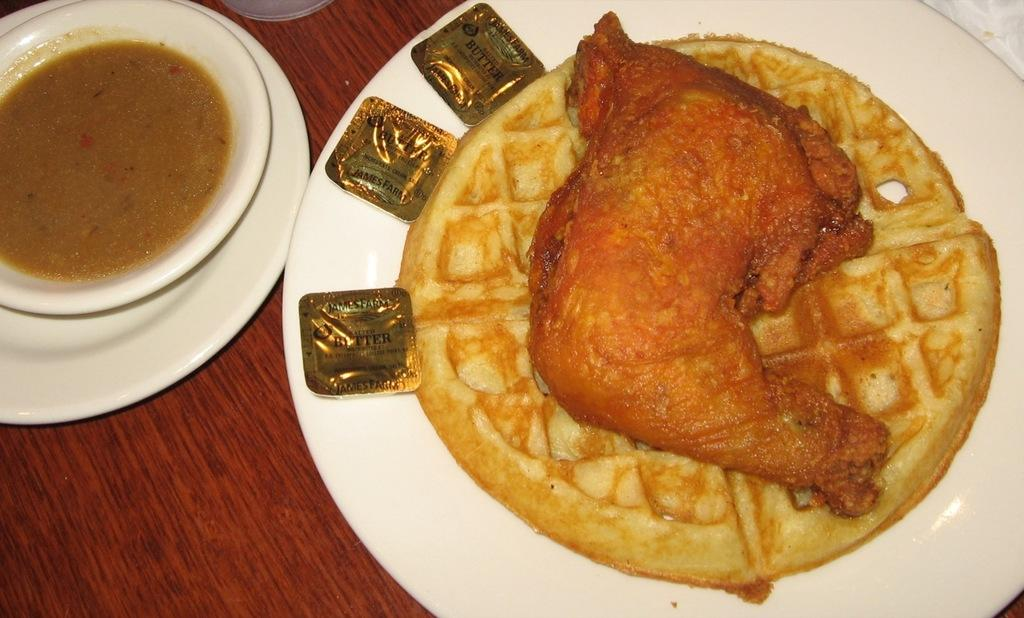What type of container is holding food items in the image? There is a plate and a bowl holding food items in the image. Are there any other containers present in the image? Yes, there is a bowl on a plate in the image. What is the surface on which the containers are placed? The objects are on a wooden surface. What is the tendency of the yak in the image? There is no yak present in the image. Can you describe the owl's behavior in the image? There is no owl present in the image. 